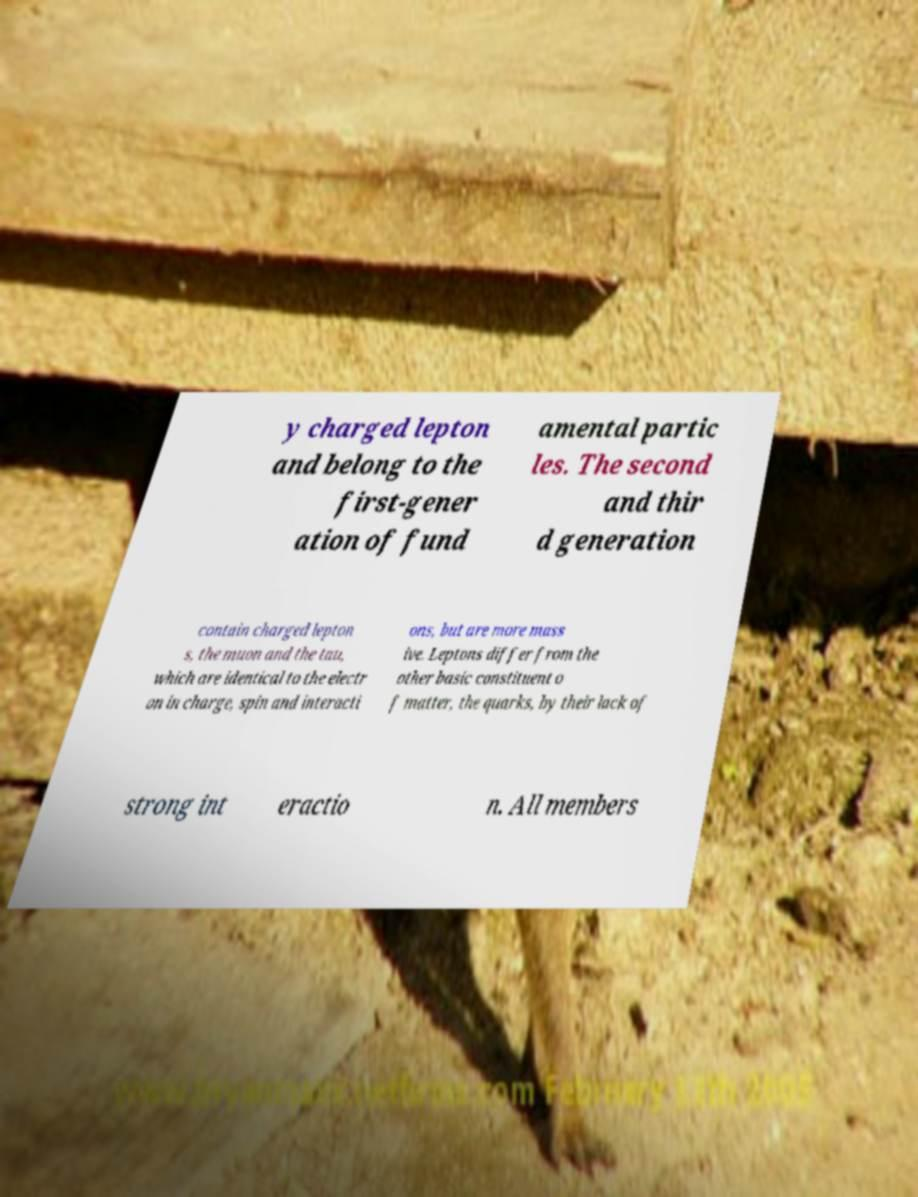Can you accurately transcribe the text from the provided image for me? y charged lepton and belong to the first-gener ation of fund amental partic les. The second and thir d generation contain charged lepton s, the muon and the tau, which are identical to the electr on in charge, spin and interacti ons, but are more mass ive. Leptons differ from the other basic constituent o f matter, the quarks, by their lack of strong int eractio n. All members 